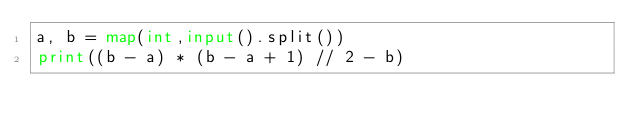<code> <loc_0><loc_0><loc_500><loc_500><_Python_>a, b = map(int,input().split())
print((b - a) * (b - a + 1) // 2 - b)</code> 